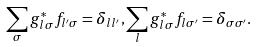<formula> <loc_0><loc_0><loc_500><loc_500>\sum _ { \sigma } g _ { l \sigma } ^ { \ast } f _ { l ^ { \prime } \sigma } = \delta _ { l l ^ { \prime } } , \sum _ { l } g _ { l \sigma } ^ { \ast } f _ { l \sigma ^ { \prime } } = \delta _ { \sigma \sigma ^ { \prime } } .</formula> 